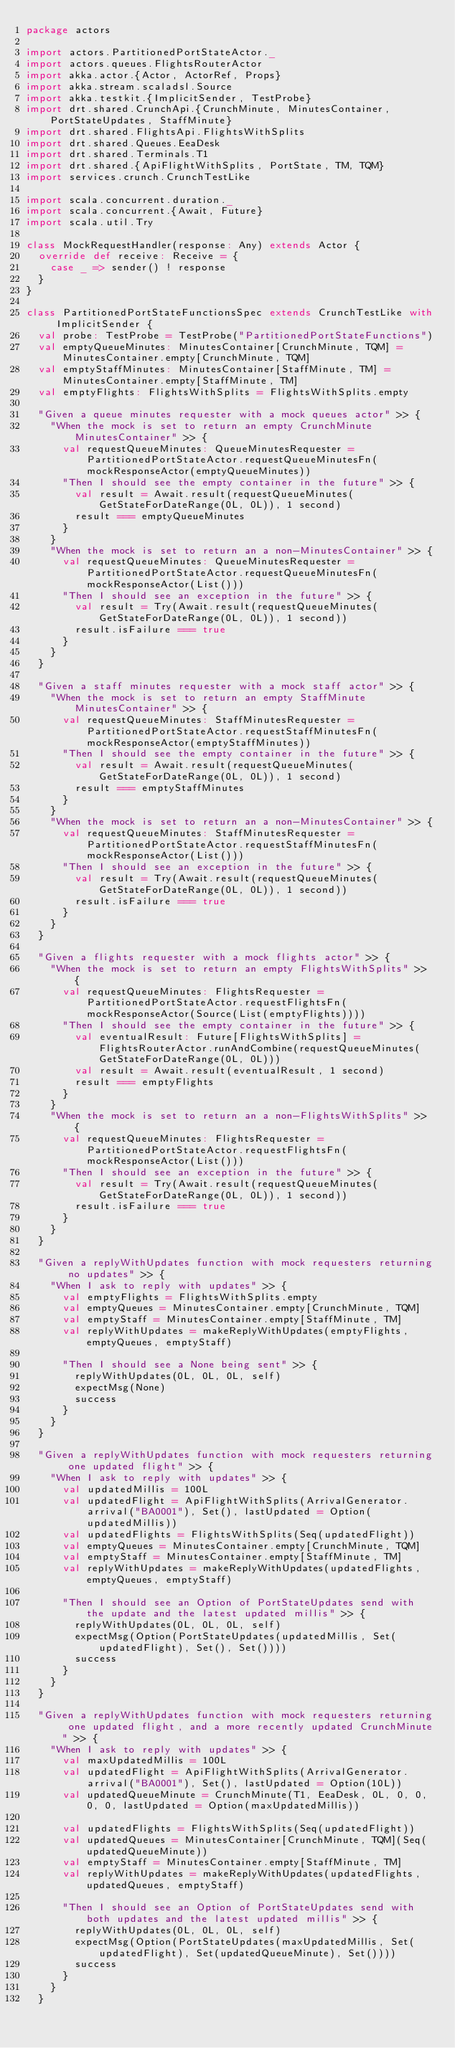Convert code to text. <code><loc_0><loc_0><loc_500><loc_500><_Scala_>package actors

import actors.PartitionedPortStateActor._
import actors.queues.FlightsRouterActor
import akka.actor.{Actor, ActorRef, Props}
import akka.stream.scaladsl.Source
import akka.testkit.{ImplicitSender, TestProbe}
import drt.shared.CrunchApi.{CrunchMinute, MinutesContainer, PortStateUpdates, StaffMinute}
import drt.shared.FlightsApi.FlightsWithSplits
import drt.shared.Queues.EeaDesk
import drt.shared.Terminals.T1
import drt.shared.{ApiFlightWithSplits, PortState, TM, TQM}
import services.crunch.CrunchTestLike

import scala.concurrent.duration._
import scala.concurrent.{Await, Future}
import scala.util.Try

class MockRequestHandler(response: Any) extends Actor {
  override def receive: Receive = {
    case _ => sender() ! response
  }
}

class PartitionedPortStateFunctionsSpec extends CrunchTestLike with ImplicitSender {
  val probe: TestProbe = TestProbe("PartitionedPortStateFunctions")
  val emptyQueueMinutes: MinutesContainer[CrunchMinute, TQM] = MinutesContainer.empty[CrunchMinute, TQM]
  val emptyStaffMinutes: MinutesContainer[StaffMinute, TM] = MinutesContainer.empty[StaffMinute, TM]
  val emptyFlights: FlightsWithSplits = FlightsWithSplits.empty

  "Given a queue minutes requester with a mock queues actor" >> {
    "When the mock is set to return an empty CrunchMinute MinutesContainer" >> {
      val requestQueueMinutes: QueueMinutesRequester = PartitionedPortStateActor.requestQueueMinutesFn(mockResponseActor(emptyQueueMinutes))
      "Then I should see the empty container in the future" >> {
        val result = Await.result(requestQueueMinutes(GetStateForDateRange(0L, 0L)), 1 second)
        result === emptyQueueMinutes
      }
    }
    "When the mock is set to return an a non-MinutesContainer" >> {
      val requestQueueMinutes: QueueMinutesRequester = PartitionedPortStateActor.requestQueueMinutesFn(mockResponseActor(List()))
      "Then I should see an exception in the future" >> {
        val result = Try(Await.result(requestQueueMinutes(GetStateForDateRange(0L, 0L)), 1 second))
        result.isFailure === true
      }
    }
  }

  "Given a staff minutes requester with a mock staff actor" >> {
    "When the mock is set to return an empty StaffMinute MinutesContainer" >> {
      val requestQueueMinutes: StaffMinutesRequester = PartitionedPortStateActor.requestStaffMinutesFn(mockResponseActor(emptyStaffMinutes))
      "Then I should see the empty container in the future" >> {
        val result = Await.result(requestQueueMinutes(GetStateForDateRange(0L, 0L)), 1 second)
        result === emptyStaffMinutes
      }
    }
    "When the mock is set to return an a non-MinutesContainer" >> {
      val requestQueueMinutes: StaffMinutesRequester = PartitionedPortStateActor.requestStaffMinutesFn(mockResponseActor(List()))
      "Then I should see an exception in the future" >> {
        val result = Try(Await.result(requestQueueMinutes(GetStateForDateRange(0L, 0L)), 1 second))
        result.isFailure === true
      }
    }
  }

  "Given a flights requester with a mock flights actor" >> {
    "When the mock is set to return an empty FlightsWithSplits" >> {
      val requestQueueMinutes: FlightsRequester = PartitionedPortStateActor.requestFlightsFn(mockResponseActor(Source(List(emptyFlights))))
      "Then I should see the empty container in the future" >> {
        val eventualResult: Future[FlightsWithSplits] = FlightsRouterActor.runAndCombine(requestQueueMinutes(GetStateForDateRange(0L, 0L)))
        val result = Await.result(eventualResult, 1 second)
        result === emptyFlights
      }
    }
    "When the mock is set to return an a non-FlightsWithSplits" >> {
      val requestQueueMinutes: FlightsRequester = PartitionedPortStateActor.requestFlightsFn(mockResponseActor(List()))
      "Then I should see an exception in the future" >> {
        val result = Try(Await.result(requestQueueMinutes(GetStateForDateRange(0L, 0L)), 1 second))
        result.isFailure === true
      }
    }
  }

  "Given a replyWithUpdates function with mock requesters returning no updates" >> {
    "When I ask to reply with updates" >> {
      val emptyFlights = FlightsWithSplits.empty
      val emptyQueues = MinutesContainer.empty[CrunchMinute, TQM]
      val emptyStaff = MinutesContainer.empty[StaffMinute, TM]
      val replyWithUpdates = makeReplyWithUpdates(emptyFlights, emptyQueues, emptyStaff)

      "Then I should see a None being sent" >> {
        replyWithUpdates(0L, 0L, 0L, self)
        expectMsg(None)
        success
      }
    }
  }

  "Given a replyWithUpdates function with mock requesters returning one updated flight" >> {
    "When I ask to reply with updates" >> {
      val updatedMillis = 100L
      val updatedFlight = ApiFlightWithSplits(ArrivalGenerator.arrival("BA0001"), Set(), lastUpdated = Option(updatedMillis))
      val updatedFlights = FlightsWithSplits(Seq(updatedFlight))
      val emptyQueues = MinutesContainer.empty[CrunchMinute, TQM]
      val emptyStaff = MinutesContainer.empty[StaffMinute, TM]
      val replyWithUpdates = makeReplyWithUpdates(updatedFlights, emptyQueues, emptyStaff)

      "Then I should see an Option of PortStateUpdates send with the update and the latest updated millis" >> {
        replyWithUpdates(0L, 0L, 0L, self)
        expectMsg(Option(PortStateUpdates(updatedMillis, Set(updatedFlight), Set(), Set())))
        success
      }
    }
  }

  "Given a replyWithUpdates function with mock requesters returning one updated flight, and a more recently updated CrunchMinute" >> {
    "When I ask to reply with updates" >> {
      val maxUpdatedMillis = 100L
      val updatedFlight = ApiFlightWithSplits(ArrivalGenerator.arrival("BA0001"), Set(), lastUpdated = Option(10L))
      val updatedQueueMinute = CrunchMinute(T1, EeaDesk, 0L, 0, 0, 0, 0, lastUpdated = Option(maxUpdatedMillis))

      val updatedFlights = FlightsWithSplits(Seq(updatedFlight))
      val updatedQueues = MinutesContainer[CrunchMinute, TQM](Seq(updatedQueueMinute))
      val emptyStaff = MinutesContainer.empty[StaffMinute, TM]
      val replyWithUpdates = makeReplyWithUpdates(updatedFlights, updatedQueues, emptyStaff)

      "Then I should see an Option of PortStateUpdates send with both updates and the latest updated millis" >> {
        replyWithUpdates(0L, 0L, 0L, self)
        expectMsg(Option(PortStateUpdates(maxUpdatedMillis, Set(updatedFlight), Set(updatedQueueMinute), Set())))
        success
      }
    }
  }
</code> 